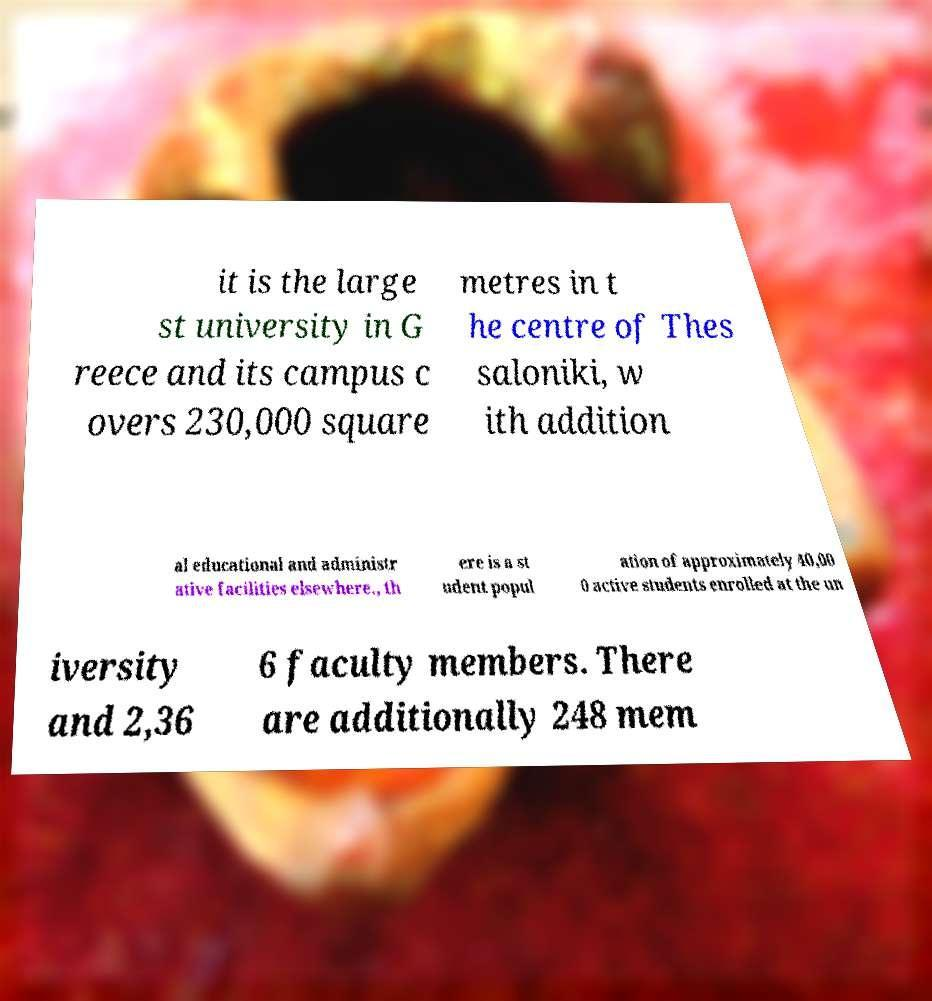Can you read and provide the text displayed in the image?This photo seems to have some interesting text. Can you extract and type it out for me? it is the large st university in G reece and its campus c overs 230,000 square metres in t he centre of Thes saloniki, w ith addition al educational and administr ative facilities elsewhere., th ere is a st udent popul ation of approximately 40,00 0 active students enrolled at the un iversity and 2,36 6 faculty members. There are additionally 248 mem 